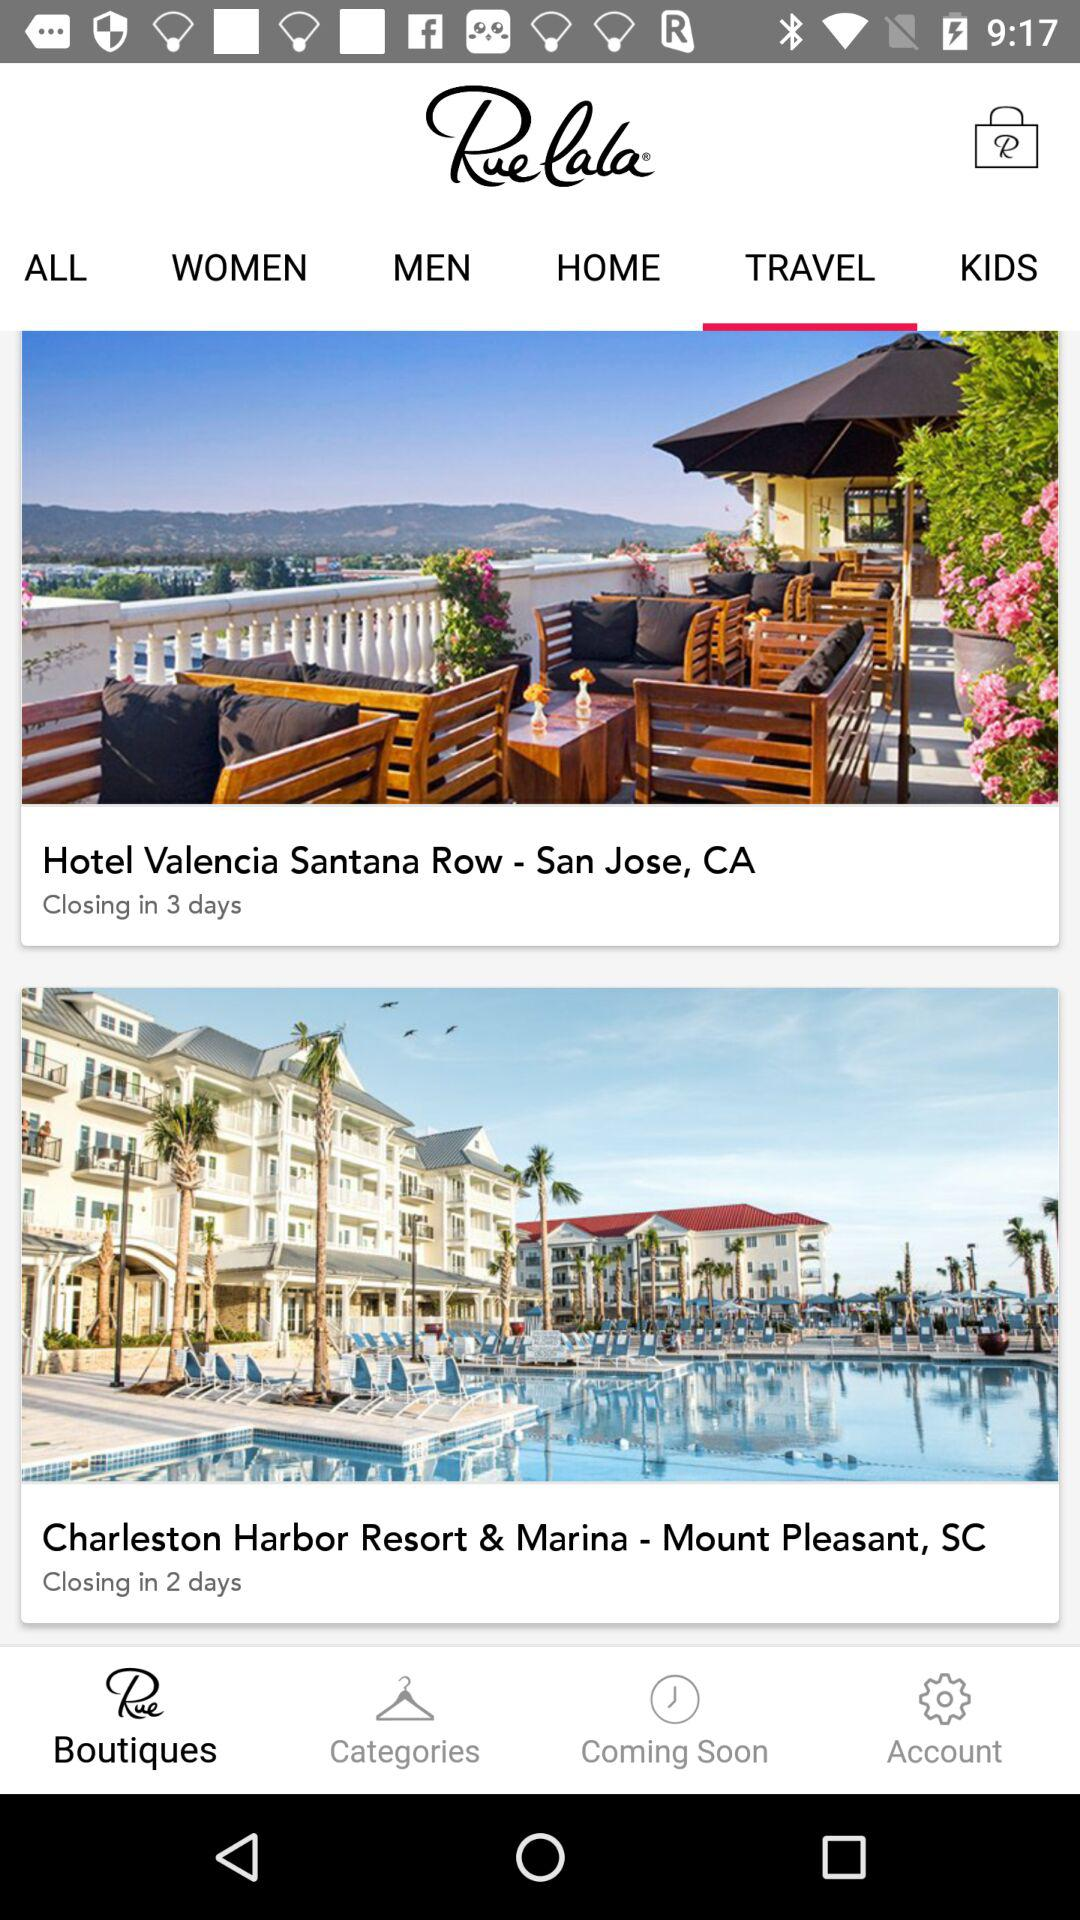Which resort is located in Mount Pleasant, SC? The resort is "Charleston Harbor Resort & Marina". 